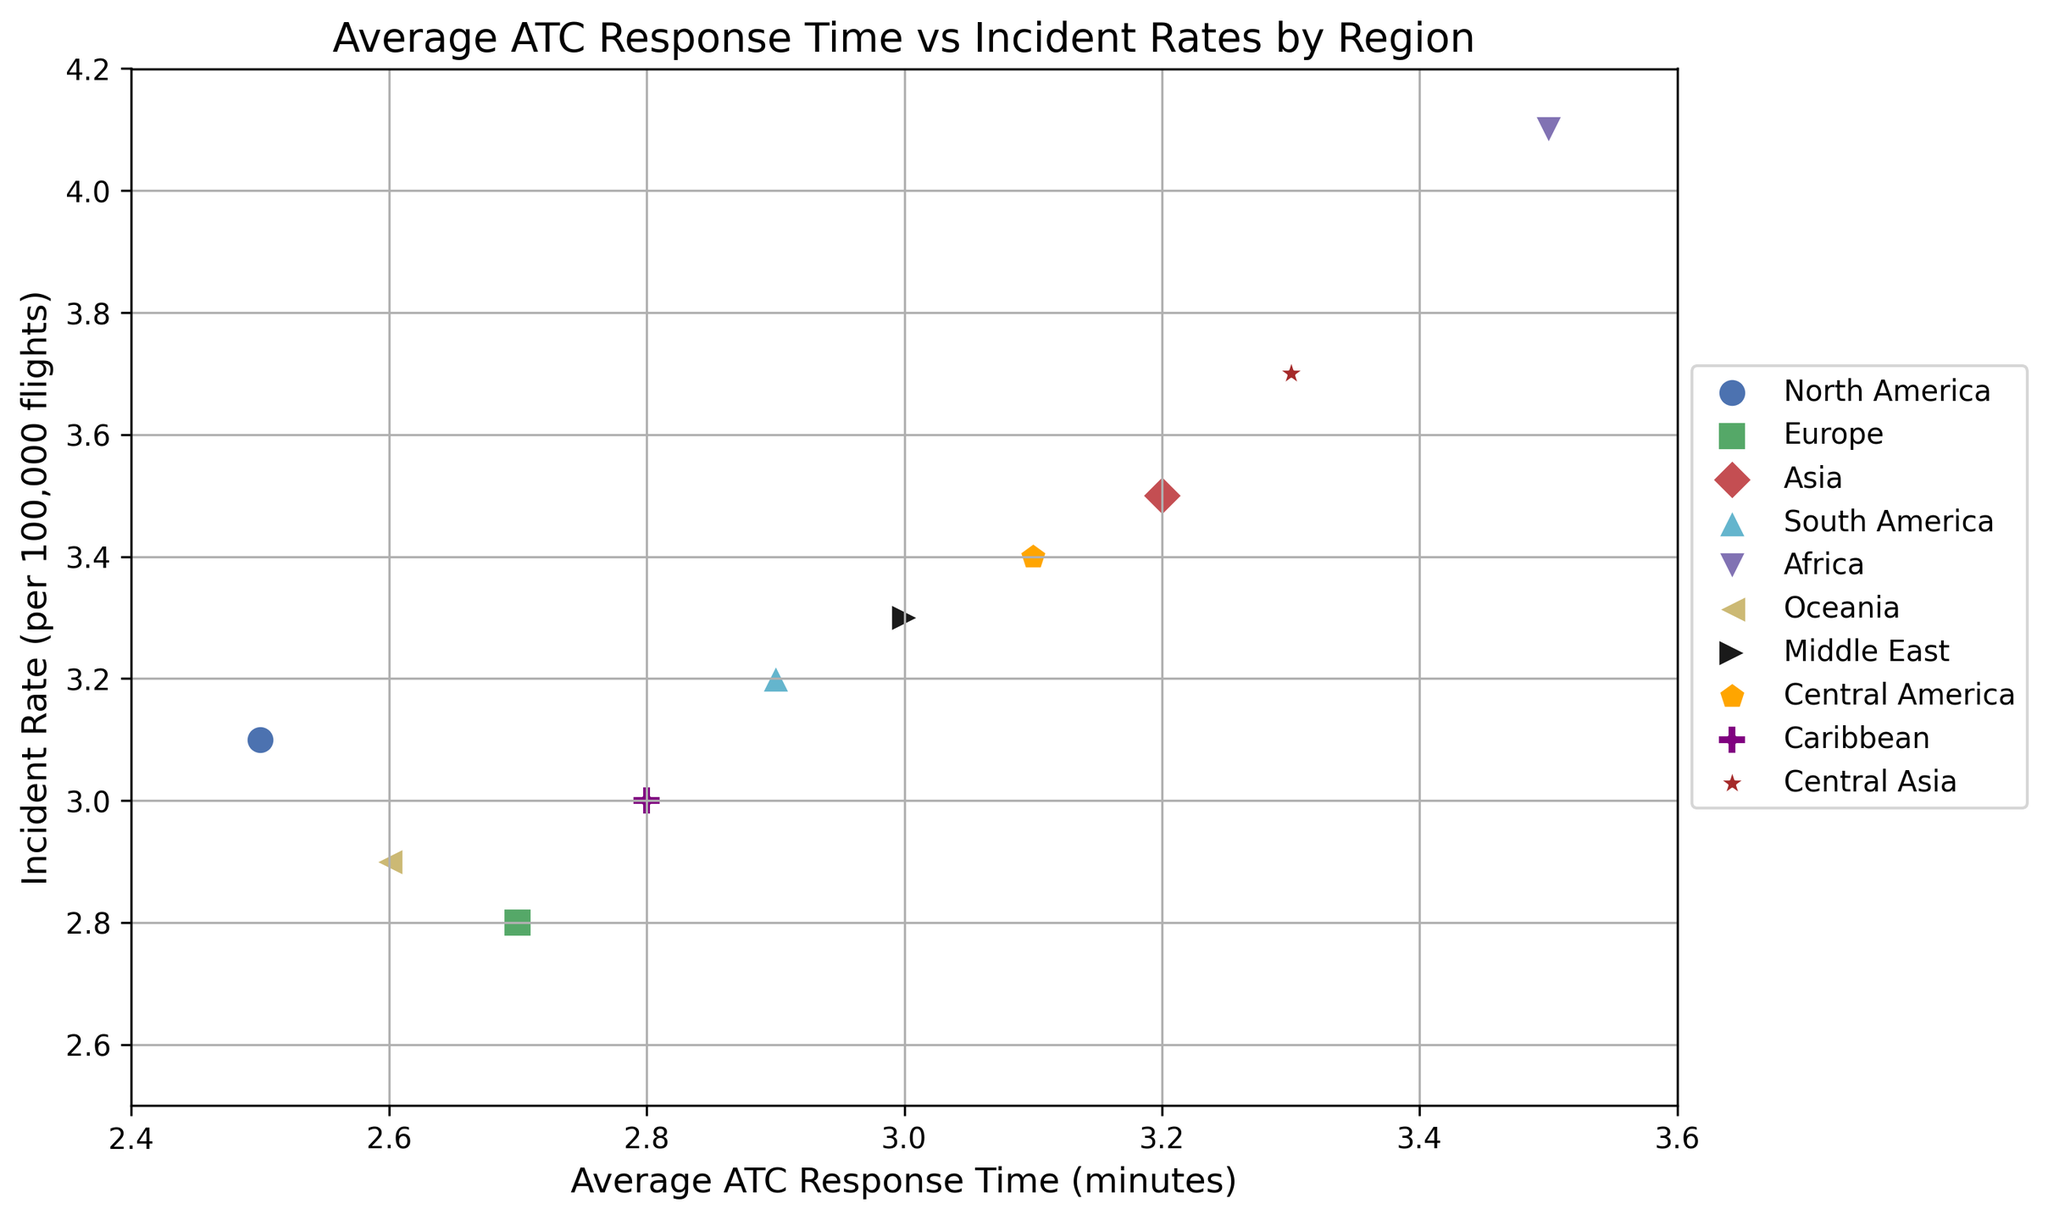Which region has the highest incident rate? By looking at the y-axis values, Africa has the highest incident rate with a value of 4.1 per 100,000 flights as indicated by the corresponding data point at the top of the plot.
Answer: Africa Which region has the lowest Average ATC Response Time? By looking at the x-axis values, North America has the lowest average ATC response time with a value of 2.5 minutes as indicated by the corresponding data point at the leftmost of the plot.
Answer: North America Among Europe and Oceania, which region has a higher incident rate? Both Europe and Oceania's data points are compared along the y-axis. Europe has an incident rate of 2.8, while Oceania has an incident rate of 2.9. Therefore, Oceania has a higher incident rate.
Answer: Oceania How many regions have an incident rate greater than 3.0? By scanning the y-axis, the regions with incident rates greater than 3.0 are North America, Asia, South America, Africa, Middle East, Central America, Caribbean, and Central Asia. Counting them gives a total of 8 regions.
Answer: 8 Which regions have an incident rate between 3.0 and 3.5 inclusive? By observing the y-axis, the regions with incident rates between 3.0 and 3.5 are North America (3.1), South America (3.2), Caribbean (3.0), Middle East (3.3), Central America (3.4), and Asia (3.5).
Answer: North America, South America, Caribbean, Middle East, Central America, Asia Is there any region with an incident rate exactly 3.0? If yes, which one? By looking at the y-axis values displayed in the scatter plot, the Caribbean region has an incident rate exactly at 3.0.
Answer: Caribbean Which region has the longest average ATC response time? By looking at the x-axis values, Africa has the longest average ATC response time at 3.5 minutes as indicated by the corresponding data point furthest to the right.
Answer: Africa Which region has the closest average ATC response time to 3.0 minutes? By examining the x-axis values, the Middle East with an average response time of 3.0 minutes is exactly at the 3.0-minute mark.
Answer: Middle East What is the difference in incident rates between Asia and Europe? By checking the y-axis values for Asia (3.5) and Europe (2.8), the difference can be calculated as 3.5 - 2.8 = 0.7.
Answer: 0.7 Which region shows a relatively higher incident rate per increase in ATC response time, Africa or Asia? By observing the plot, both Africa and Asia have similar average ATC response times (3.5 for Africa and 3.2 for Asia) but Africa has a higher incident rate of 4.1 compared to Asia's 3.5. Therefore, as the ATC response time increases, Africa shows a relatively higher incident rate.
Answer: Africa 